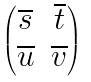<formula> <loc_0><loc_0><loc_500><loc_500>\begin{pmatrix} \overline { s } & \overline { t } \\ \overline { u } & \overline { v } \\ \end{pmatrix}</formula> 